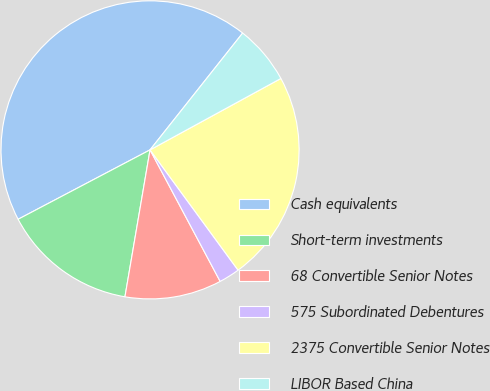<chart> <loc_0><loc_0><loc_500><loc_500><pie_chart><fcel>Cash equivalents<fcel>Short-term investments<fcel>68 Convertible Senior Notes<fcel>575 Subordinated Debentures<fcel>2375 Convertible Senior Notes<fcel>LIBOR Based China<nl><fcel>43.38%<fcel>14.6%<fcel>10.49%<fcel>2.26%<fcel>22.9%<fcel>6.38%<nl></chart> 